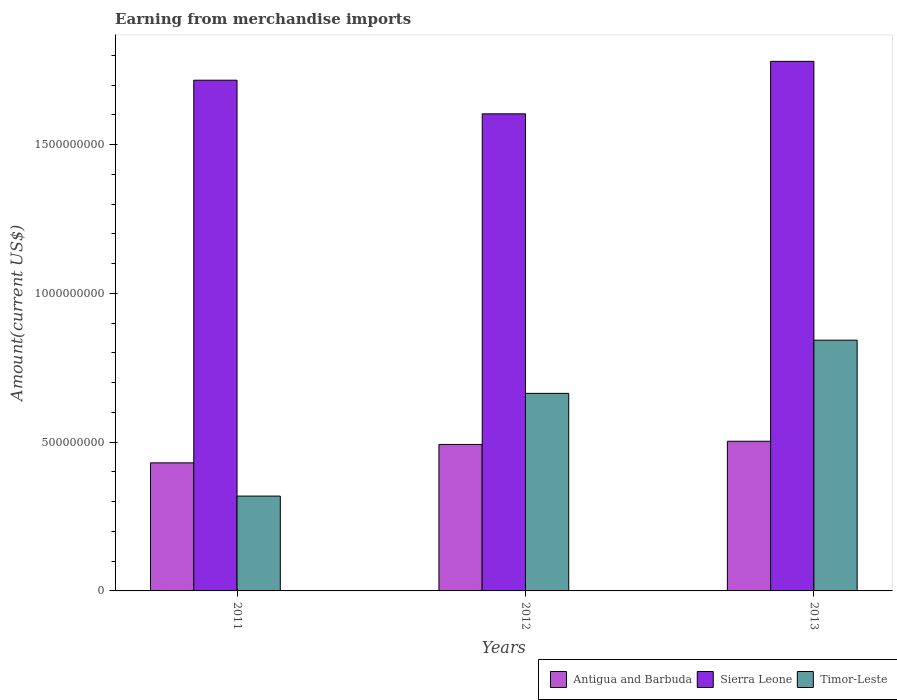Are the number of bars per tick equal to the number of legend labels?
Offer a terse response. Yes. How many bars are there on the 2nd tick from the right?
Offer a terse response. 3. What is the label of the 1st group of bars from the left?
Your response must be concise. 2011. In how many cases, is the number of bars for a given year not equal to the number of legend labels?
Make the answer very short. 0. What is the amount earned from merchandise imports in Antigua and Barbuda in 2012?
Keep it short and to the point. 4.92e+08. Across all years, what is the maximum amount earned from merchandise imports in Timor-Leste?
Make the answer very short. 8.43e+08. Across all years, what is the minimum amount earned from merchandise imports in Timor-Leste?
Offer a terse response. 3.19e+08. In which year was the amount earned from merchandise imports in Sierra Leone maximum?
Offer a very short reply. 2013. What is the total amount earned from merchandise imports in Timor-Leste in the graph?
Your response must be concise. 1.83e+09. What is the difference between the amount earned from merchandise imports in Sierra Leone in 2011 and that in 2012?
Your answer should be compact. 1.13e+08. What is the difference between the amount earned from merchandise imports in Timor-Leste in 2011 and the amount earned from merchandise imports in Antigua and Barbuda in 2013?
Offer a very short reply. -1.84e+08. What is the average amount earned from merchandise imports in Antigua and Barbuda per year?
Ensure brevity in your answer.  4.75e+08. In the year 2011, what is the difference between the amount earned from merchandise imports in Sierra Leone and amount earned from merchandise imports in Timor-Leste?
Make the answer very short. 1.40e+09. What is the ratio of the amount earned from merchandise imports in Sierra Leone in 2011 to that in 2012?
Your answer should be very brief. 1.07. Is the difference between the amount earned from merchandise imports in Sierra Leone in 2011 and 2012 greater than the difference between the amount earned from merchandise imports in Timor-Leste in 2011 and 2012?
Offer a very short reply. Yes. What is the difference between the highest and the second highest amount earned from merchandise imports in Timor-Leste?
Offer a very short reply. 1.79e+08. What is the difference between the highest and the lowest amount earned from merchandise imports in Timor-Leste?
Keep it short and to the point. 5.24e+08. Is the sum of the amount earned from merchandise imports in Sierra Leone in 2012 and 2013 greater than the maximum amount earned from merchandise imports in Antigua and Barbuda across all years?
Your answer should be very brief. Yes. What does the 2nd bar from the left in 2013 represents?
Your response must be concise. Sierra Leone. What does the 2nd bar from the right in 2013 represents?
Give a very brief answer. Sierra Leone. Is it the case that in every year, the sum of the amount earned from merchandise imports in Timor-Leste and amount earned from merchandise imports in Antigua and Barbuda is greater than the amount earned from merchandise imports in Sierra Leone?
Offer a very short reply. No. How many bars are there?
Make the answer very short. 9. Are all the bars in the graph horizontal?
Offer a terse response. No. What is the difference between two consecutive major ticks on the Y-axis?
Give a very brief answer. 5.00e+08. Are the values on the major ticks of Y-axis written in scientific E-notation?
Your answer should be very brief. No. What is the title of the graph?
Offer a terse response. Earning from merchandise imports. Does "Congo (Democratic)" appear as one of the legend labels in the graph?
Your answer should be compact. No. What is the label or title of the X-axis?
Give a very brief answer. Years. What is the label or title of the Y-axis?
Your answer should be compact. Amount(current US$). What is the Amount(current US$) in Antigua and Barbuda in 2011?
Provide a short and direct response. 4.30e+08. What is the Amount(current US$) in Sierra Leone in 2011?
Provide a succinct answer. 1.72e+09. What is the Amount(current US$) of Timor-Leste in 2011?
Offer a terse response. 3.19e+08. What is the Amount(current US$) of Antigua and Barbuda in 2012?
Offer a very short reply. 4.92e+08. What is the Amount(current US$) in Sierra Leone in 2012?
Provide a succinct answer. 1.60e+09. What is the Amount(current US$) of Timor-Leste in 2012?
Your answer should be compact. 6.64e+08. What is the Amount(current US$) in Antigua and Barbuda in 2013?
Your answer should be very brief. 5.03e+08. What is the Amount(current US$) of Sierra Leone in 2013?
Your answer should be very brief. 1.78e+09. What is the Amount(current US$) of Timor-Leste in 2013?
Ensure brevity in your answer.  8.43e+08. Across all years, what is the maximum Amount(current US$) of Antigua and Barbuda?
Offer a very short reply. 5.03e+08. Across all years, what is the maximum Amount(current US$) in Sierra Leone?
Offer a terse response. 1.78e+09. Across all years, what is the maximum Amount(current US$) in Timor-Leste?
Your answer should be very brief. 8.43e+08. Across all years, what is the minimum Amount(current US$) of Antigua and Barbuda?
Ensure brevity in your answer.  4.30e+08. Across all years, what is the minimum Amount(current US$) of Sierra Leone?
Offer a terse response. 1.60e+09. Across all years, what is the minimum Amount(current US$) in Timor-Leste?
Provide a succinct answer. 3.19e+08. What is the total Amount(current US$) of Antigua and Barbuda in the graph?
Offer a terse response. 1.43e+09. What is the total Amount(current US$) of Sierra Leone in the graph?
Ensure brevity in your answer.  5.10e+09. What is the total Amount(current US$) of Timor-Leste in the graph?
Offer a terse response. 1.83e+09. What is the difference between the Amount(current US$) in Antigua and Barbuda in 2011 and that in 2012?
Offer a terse response. -6.19e+07. What is the difference between the Amount(current US$) in Sierra Leone in 2011 and that in 2012?
Ensure brevity in your answer.  1.13e+08. What is the difference between the Amount(current US$) in Timor-Leste in 2011 and that in 2012?
Give a very brief answer. -3.45e+08. What is the difference between the Amount(current US$) of Antigua and Barbuda in 2011 and that in 2013?
Your response must be concise. -7.26e+07. What is the difference between the Amount(current US$) of Sierra Leone in 2011 and that in 2013?
Your answer should be very brief. -6.34e+07. What is the difference between the Amount(current US$) of Timor-Leste in 2011 and that in 2013?
Provide a short and direct response. -5.24e+08. What is the difference between the Amount(current US$) in Antigua and Barbuda in 2012 and that in 2013?
Keep it short and to the point. -1.07e+07. What is the difference between the Amount(current US$) of Sierra Leone in 2012 and that in 2013?
Keep it short and to the point. -1.76e+08. What is the difference between the Amount(current US$) of Timor-Leste in 2012 and that in 2013?
Your answer should be compact. -1.79e+08. What is the difference between the Amount(current US$) of Antigua and Barbuda in 2011 and the Amount(current US$) of Sierra Leone in 2012?
Give a very brief answer. -1.17e+09. What is the difference between the Amount(current US$) of Antigua and Barbuda in 2011 and the Amount(current US$) of Timor-Leste in 2012?
Give a very brief answer. -2.34e+08. What is the difference between the Amount(current US$) of Sierra Leone in 2011 and the Amount(current US$) of Timor-Leste in 2012?
Your answer should be very brief. 1.05e+09. What is the difference between the Amount(current US$) in Antigua and Barbuda in 2011 and the Amount(current US$) in Sierra Leone in 2013?
Give a very brief answer. -1.35e+09. What is the difference between the Amount(current US$) of Antigua and Barbuda in 2011 and the Amount(current US$) of Timor-Leste in 2013?
Your response must be concise. -4.12e+08. What is the difference between the Amount(current US$) of Sierra Leone in 2011 and the Amount(current US$) of Timor-Leste in 2013?
Your answer should be very brief. 8.74e+08. What is the difference between the Amount(current US$) in Antigua and Barbuda in 2012 and the Amount(current US$) in Sierra Leone in 2013?
Your response must be concise. -1.29e+09. What is the difference between the Amount(current US$) of Antigua and Barbuda in 2012 and the Amount(current US$) of Timor-Leste in 2013?
Your answer should be compact. -3.50e+08. What is the difference between the Amount(current US$) in Sierra Leone in 2012 and the Amount(current US$) in Timor-Leste in 2013?
Make the answer very short. 7.61e+08. What is the average Amount(current US$) of Antigua and Barbuda per year?
Make the answer very short. 4.75e+08. What is the average Amount(current US$) of Sierra Leone per year?
Provide a succinct answer. 1.70e+09. What is the average Amount(current US$) in Timor-Leste per year?
Provide a succinct answer. 6.09e+08. In the year 2011, what is the difference between the Amount(current US$) in Antigua and Barbuda and Amount(current US$) in Sierra Leone?
Provide a succinct answer. -1.29e+09. In the year 2011, what is the difference between the Amount(current US$) of Antigua and Barbuda and Amount(current US$) of Timor-Leste?
Keep it short and to the point. 1.12e+08. In the year 2011, what is the difference between the Amount(current US$) of Sierra Leone and Amount(current US$) of Timor-Leste?
Give a very brief answer. 1.40e+09. In the year 2012, what is the difference between the Amount(current US$) of Antigua and Barbuda and Amount(current US$) of Sierra Leone?
Your response must be concise. -1.11e+09. In the year 2012, what is the difference between the Amount(current US$) in Antigua and Barbuda and Amount(current US$) in Timor-Leste?
Offer a very short reply. -1.72e+08. In the year 2012, what is the difference between the Amount(current US$) in Sierra Leone and Amount(current US$) in Timor-Leste?
Provide a short and direct response. 9.40e+08. In the year 2013, what is the difference between the Amount(current US$) of Antigua and Barbuda and Amount(current US$) of Sierra Leone?
Make the answer very short. -1.28e+09. In the year 2013, what is the difference between the Amount(current US$) in Antigua and Barbuda and Amount(current US$) in Timor-Leste?
Make the answer very short. -3.40e+08. In the year 2013, what is the difference between the Amount(current US$) of Sierra Leone and Amount(current US$) of Timor-Leste?
Provide a short and direct response. 9.37e+08. What is the ratio of the Amount(current US$) in Antigua and Barbuda in 2011 to that in 2012?
Ensure brevity in your answer.  0.87. What is the ratio of the Amount(current US$) in Sierra Leone in 2011 to that in 2012?
Give a very brief answer. 1.07. What is the ratio of the Amount(current US$) of Timor-Leste in 2011 to that in 2012?
Ensure brevity in your answer.  0.48. What is the ratio of the Amount(current US$) in Antigua and Barbuda in 2011 to that in 2013?
Your answer should be compact. 0.86. What is the ratio of the Amount(current US$) of Sierra Leone in 2011 to that in 2013?
Your answer should be compact. 0.96. What is the ratio of the Amount(current US$) in Timor-Leste in 2011 to that in 2013?
Provide a short and direct response. 0.38. What is the ratio of the Amount(current US$) in Antigua and Barbuda in 2012 to that in 2013?
Give a very brief answer. 0.98. What is the ratio of the Amount(current US$) in Sierra Leone in 2012 to that in 2013?
Offer a very short reply. 0.9. What is the ratio of the Amount(current US$) in Timor-Leste in 2012 to that in 2013?
Offer a very short reply. 0.79. What is the difference between the highest and the second highest Amount(current US$) of Antigua and Barbuda?
Provide a succinct answer. 1.07e+07. What is the difference between the highest and the second highest Amount(current US$) of Sierra Leone?
Keep it short and to the point. 6.34e+07. What is the difference between the highest and the second highest Amount(current US$) of Timor-Leste?
Make the answer very short. 1.79e+08. What is the difference between the highest and the lowest Amount(current US$) of Antigua and Barbuda?
Ensure brevity in your answer.  7.26e+07. What is the difference between the highest and the lowest Amount(current US$) of Sierra Leone?
Offer a terse response. 1.76e+08. What is the difference between the highest and the lowest Amount(current US$) in Timor-Leste?
Your answer should be very brief. 5.24e+08. 